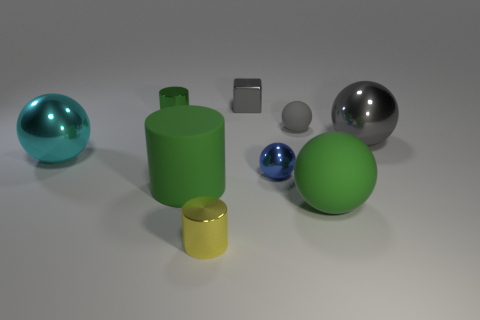There is a shiny ball that is behind the large sphere left of the green shiny cylinder; what size is it?
Offer a terse response. Large. What number of tiny spheres have the same color as the big cylinder?
Keep it short and to the point. 0. What number of metallic cylinders are there?
Your response must be concise. 2. How many other big green spheres have the same material as the green sphere?
Ensure brevity in your answer.  0. There is a gray metal object that is the same shape as the cyan thing; what is its size?
Your answer should be compact. Large. What is the material of the tiny gray ball?
Offer a terse response. Rubber. What is the material of the green cylinder behind the big green rubber object that is behind the green object to the right of the small gray matte thing?
Your answer should be very brief. Metal. Are there any other things that have the same shape as the cyan metallic thing?
Make the answer very short. Yes. What color is the other small thing that is the same shape as the blue metal object?
Your answer should be compact. Gray. There is a big rubber cylinder that is in front of the small green object; is its color the same as the big metallic object on the left side of the green metal cylinder?
Your answer should be compact. No. 